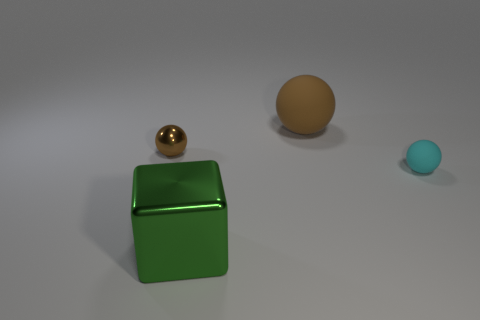Are there any big brown things that have the same material as the big green object?
Make the answer very short. No. Is the size of the rubber ball in front of the metal sphere the same as the big brown thing?
Ensure brevity in your answer.  No. There is a large object behind the ball on the left side of the large sphere; are there any tiny brown objects that are behind it?
Provide a succinct answer. No. How many matte objects are either big gray balls or cyan objects?
Provide a short and direct response. 1. What number of other things are there of the same shape as the big green thing?
Your answer should be very brief. 0. Is the number of big balls greater than the number of red matte blocks?
Provide a short and direct response. Yes. What size is the rubber sphere behind the brown ball that is in front of the brown sphere behind the metal sphere?
Give a very brief answer. Large. How big is the ball to the left of the big green thing?
Offer a terse response. Small. How many things are either small blue blocks or matte objects that are behind the tiny metallic object?
Offer a very short reply. 1. How many other objects are there of the same size as the brown metal thing?
Offer a very short reply. 1. 